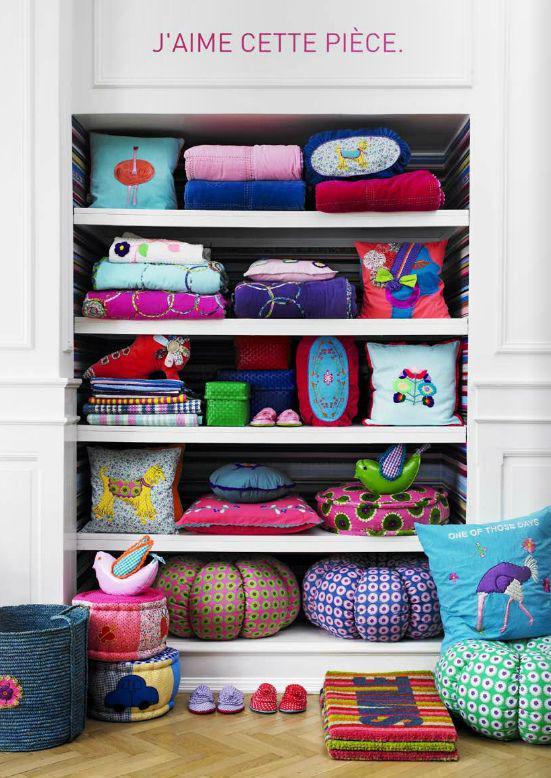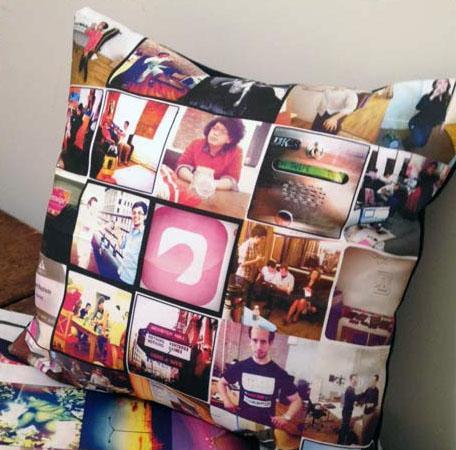The first image is the image on the left, the second image is the image on the right. Examine the images to the left and right. Is the description "At least one image has no more than two pillows." accurate? Answer yes or no. Yes. The first image is the image on the left, the second image is the image on the right. Evaluate the accuracy of this statement regarding the images: "The sofa in the image on the left is buried in pillows". Is it true? Answer yes or no. No. 